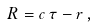<formula> <loc_0><loc_0><loc_500><loc_500>R = c \, \tau - r \, ,</formula> 